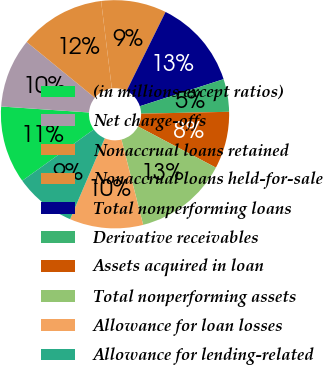<chart> <loc_0><loc_0><loc_500><loc_500><pie_chart><fcel>(in millions except ratios)<fcel>Net charge-offs<fcel>Nonaccrual loans retained<fcel>Nonaccrual loans held-for-sale<fcel>Total nonperforming loans<fcel>Derivative receivables<fcel>Assets acquired in loan<fcel>Total nonperforming assets<fcel>Allowance for loan losses<fcel>Allowance for lending-related<nl><fcel>10.98%<fcel>9.83%<fcel>12.14%<fcel>9.25%<fcel>12.72%<fcel>4.63%<fcel>8.09%<fcel>13.29%<fcel>10.4%<fcel>8.67%<nl></chart> 